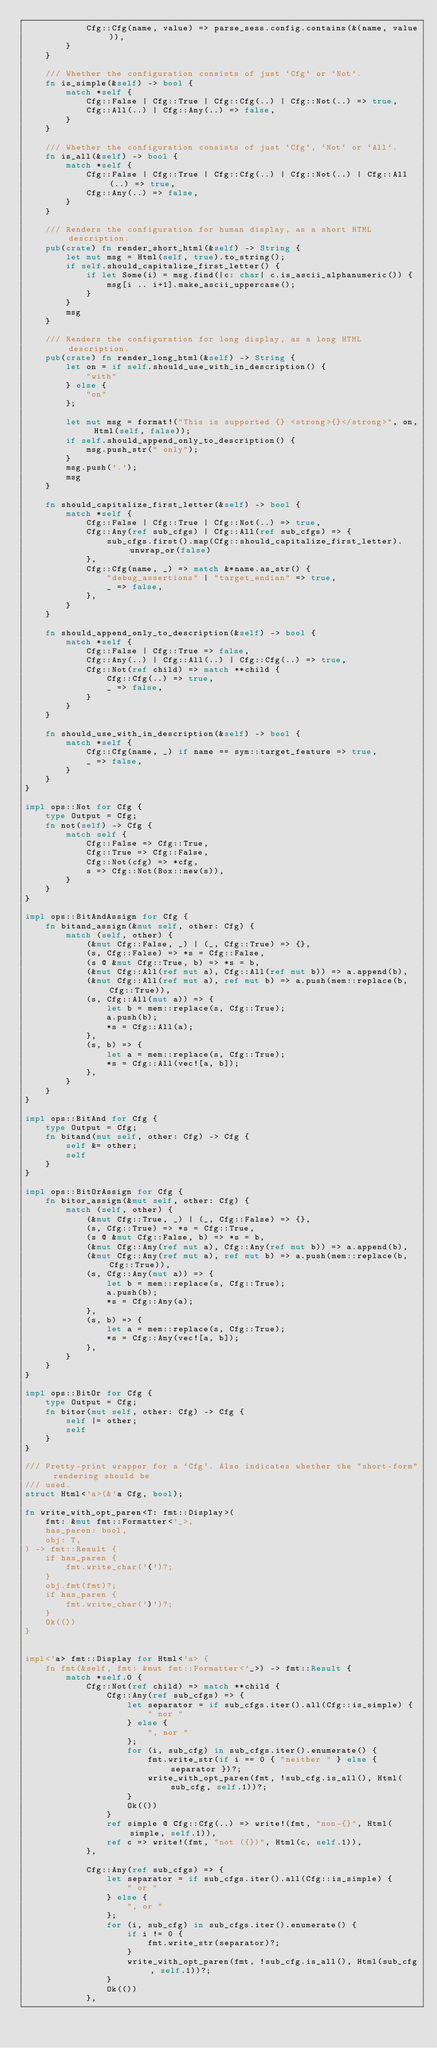<code> <loc_0><loc_0><loc_500><loc_500><_Rust_>            Cfg::Cfg(name, value) => parse_sess.config.contains(&(name, value)),
        }
    }

    /// Whether the configuration consists of just `Cfg` or `Not`.
    fn is_simple(&self) -> bool {
        match *self {
            Cfg::False | Cfg::True | Cfg::Cfg(..) | Cfg::Not(..) => true,
            Cfg::All(..) | Cfg::Any(..) => false,
        }
    }

    /// Whether the configuration consists of just `Cfg`, `Not` or `All`.
    fn is_all(&self) -> bool {
        match *self {
            Cfg::False | Cfg::True | Cfg::Cfg(..) | Cfg::Not(..) | Cfg::All(..) => true,
            Cfg::Any(..) => false,
        }
    }

    /// Renders the configuration for human display, as a short HTML description.
    pub(crate) fn render_short_html(&self) -> String {
        let mut msg = Html(self, true).to_string();
        if self.should_capitalize_first_letter() {
            if let Some(i) = msg.find(|c: char| c.is_ascii_alphanumeric()) {
                msg[i .. i+1].make_ascii_uppercase();
            }
        }
        msg
    }

    /// Renders the configuration for long display, as a long HTML description.
    pub(crate) fn render_long_html(&self) -> String {
        let on = if self.should_use_with_in_description() {
            "with"
        } else {
            "on"
        };

        let mut msg = format!("This is supported {} <strong>{}</strong>", on, Html(self, false));
        if self.should_append_only_to_description() {
            msg.push_str(" only");
        }
        msg.push('.');
        msg
    }

    fn should_capitalize_first_letter(&self) -> bool {
        match *self {
            Cfg::False | Cfg::True | Cfg::Not(..) => true,
            Cfg::Any(ref sub_cfgs) | Cfg::All(ref sub_cfgs) => {
                sub_cfgs.first().map(Cfg::should_capitalize_first_letter).unwrap_or(false)
            },
            Cfg::Cfg(name, _) => match &*name.as_str() {
                "debug_assertions" | "target_endian" => true,
                _ => false,
            },
        }
    }

    fn should_append_only_to_description(&self) -> bool {
        match *self {
            Cfg::False | Cfg::True => false,
            Cfg::Any(..) | Cfg::All(..) | Cfg::Cfg(..) => true,
            Cfg::Not(ref child) => match **child {
                Cfg::Cfg(..) => true,
                _ => false,
            }
        }
    }

    fn should_use_with_in_description(&self) -> bool {
        match *self {
            Cfg::Cfg(name, _) if name == sym::target_feature => true,
            _ => false,
        }
    }
}

impl ops::Not for Cfg {
    type Output = Cfg;
    fn not(self) -> Cfg {
        match self {
            Cfg::False => Cfg::True,
            Cfg::True => Cfg::False,
            Cfg::Not(cfg) => *cfg,
            s => Cfg::Not(Box::new(s)),
        }
    }
}

impl ops::BitAndAssign for Cfg {
    fn bitand_assign(&mut self, other: Cfg) {
        match (self, other) {
            (&mut Cfg::False, _) | (_, Cfg::True) => {},
            (s, Cfg::False) => *s = Cfg::False,
            (s @ &mut Cfg::True, b) => *s = b,
            (&mut Cfg::All(ref mut a), Cfg::All(ref mut b)) => a.append(b),
            (&mut Cfg::All(ref mut a), ref mut b) => a.push(mem::replace(b, Cfg::True)),
            (s, Cfg::All(mut a)) => {
                let b = mem::replace(s, Cfg::True);
                a.push(b);
                *s = Cfg::All(a);
            },
            (s, b) => {
                let a = mem::replace(s, Cfg::True);
                *s = Cfg::All(vec![a, b]);
            },
        }
    }
}

impl ops::BitAnd for Cfg {
    type Output = Cfg;
    fn bitand(mut self, other: Cfg) -> Cfg {
        self &= other;
        self
    }
}

impl ops::BitOrAssign for Cfg {
    fn bitor_assign(&mut self, other: Cfg) {
        match (self, other) {
            (&mut Cfg::True, _) | (_, Cfg::False) => {},
            (s, Cfg::True) => *s = Cfg::True,
            (s @ &mut Cfg::False, b) => *s = b,
            (&mut Cfg::Any(ref mut a), Cfg::Any(ref mut b)) => a.append(b),
            (&mut Cfg::Any(ref mut a), ref mut b) => a.push(mem::replace(b, Cfg::True)),
            (s, Cfg::Any(mut a)) => {
                let b = mem::replace(s, Cfg::True);
                a.push(b);
                *s = Cfg::Any(a);
            },
            (s, b) => {
                let a = mem::replace(s, Cfg::True);
                *s = Cfg::Any(vec![a, b]);
            },
        }
    }
}

impl ops::BitOr for Cfg {
    type Output = Cfg;
    fn bitor(mut self, other: Cfg) -> Cfg {
        self |= other;
        self
    }
}

/// Pretty-print wrapper for a `Cfg`. Also indicates whether the "short-form" rendering should be
/// used.
struct Html<'a>(&'a Cfg, bool);

fn write_with_opt_paren<T: fmt::Display>(
    fmt: &mut fmt::Formatter<'_>,
    has_paren: bool,
    obj: T,
) -> fmt::Result {
    if has_paren {
        fmt.write_char('(')?;
    }
    obj.fmt(fmt)?;
    if has_paren {
        fmt.write_char(')')?;
    }
    Ok(())
}


impl<'a> fmt::Display for Html<'a> {
    fn fmt(&self, fmt: &mut fmt::Formatter<'_>) -> fmt::Result {
        match *self.0 {
            Cfg::Not(ref child) => match **child {
                Cfg::Any(ref sub_cfgs) => {
                    let separator = if sub_cfgs.iter().all(Cfg::is_simple) {
                        " nor "
                    } else {
                        ", nor "
                    };
                    for (i, sub_cfg) in sub_cfgs.iter().enumerate() {
                        fmt.write_str(if i == 0 { "neither " } else { separator })?;
                        write_with_opt_paren(fmt, !sub_cfg.is_all(), Html(sub_cfg, self.1))?;
                    }
                    Ok(())
                }
                ref simple @ Cfg::Cfg(..) => write!(fmt, "non-{}", Html(simple, self.1)),
                ref c => write!(fmt, "not ({})", Html(c, self.1)),
            },

            Cfg::Any(ref sub_cfgs) => {
                let separator = if sub_cfgs.iter().all(Cfg::is_simple) {
                    " or "
                } else {
                    ", or "
                };
                for (i, sub_cfg) in sub_cfgs.iter().enumerate() {
                    if i != 0 {
                        fmt.write_str(separator)?;
                    }
                    write_with_opt_paren(fmt, !sub_cfg.is_all(), Html(sub_cfg, self.1))?;
                }
                Ok(())
            },
</code> 